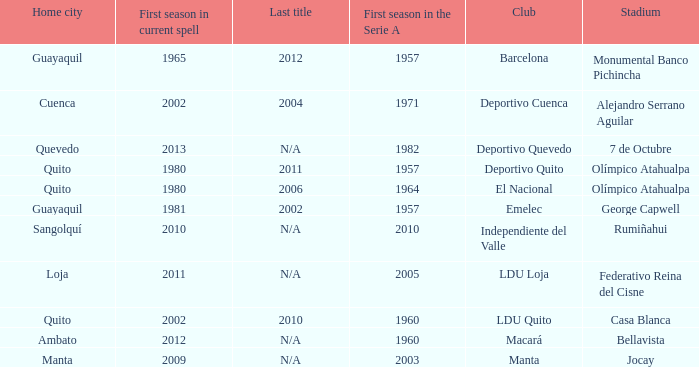Name the last title for 2012 N/A. 